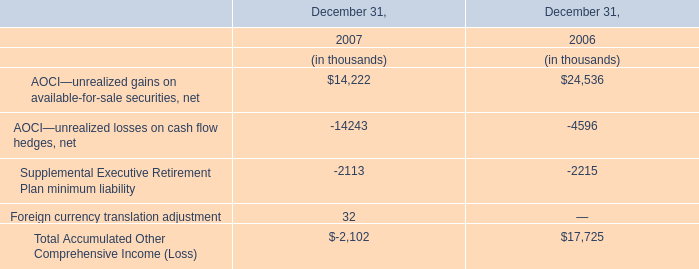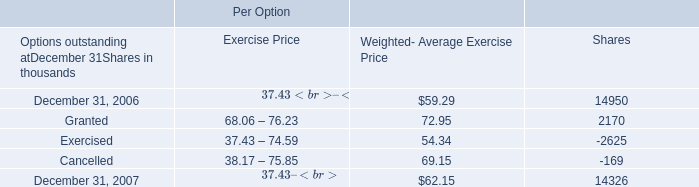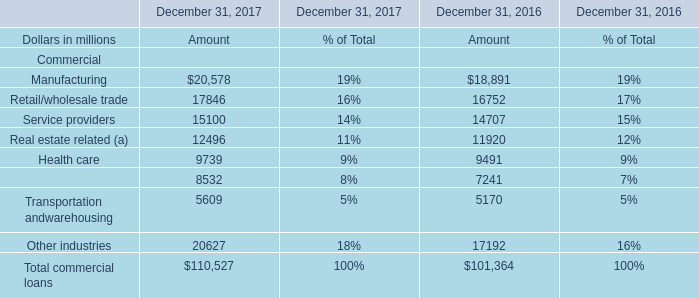What is the ratio of all elements for Amount that are smaller than 10000 to the sum of elements, in 2017? 
Computations: (((9739 + 8532) + 5609) / 110527)
Answer: 0.21606. 